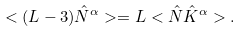<formula> <loc_0><loc_0><loc_500><loc_500>< ( L - 3 ) \hat { N } ^ { \alpha } > = L < \hat { N } \hat { K } ^ { \alpha } > .</formula> 